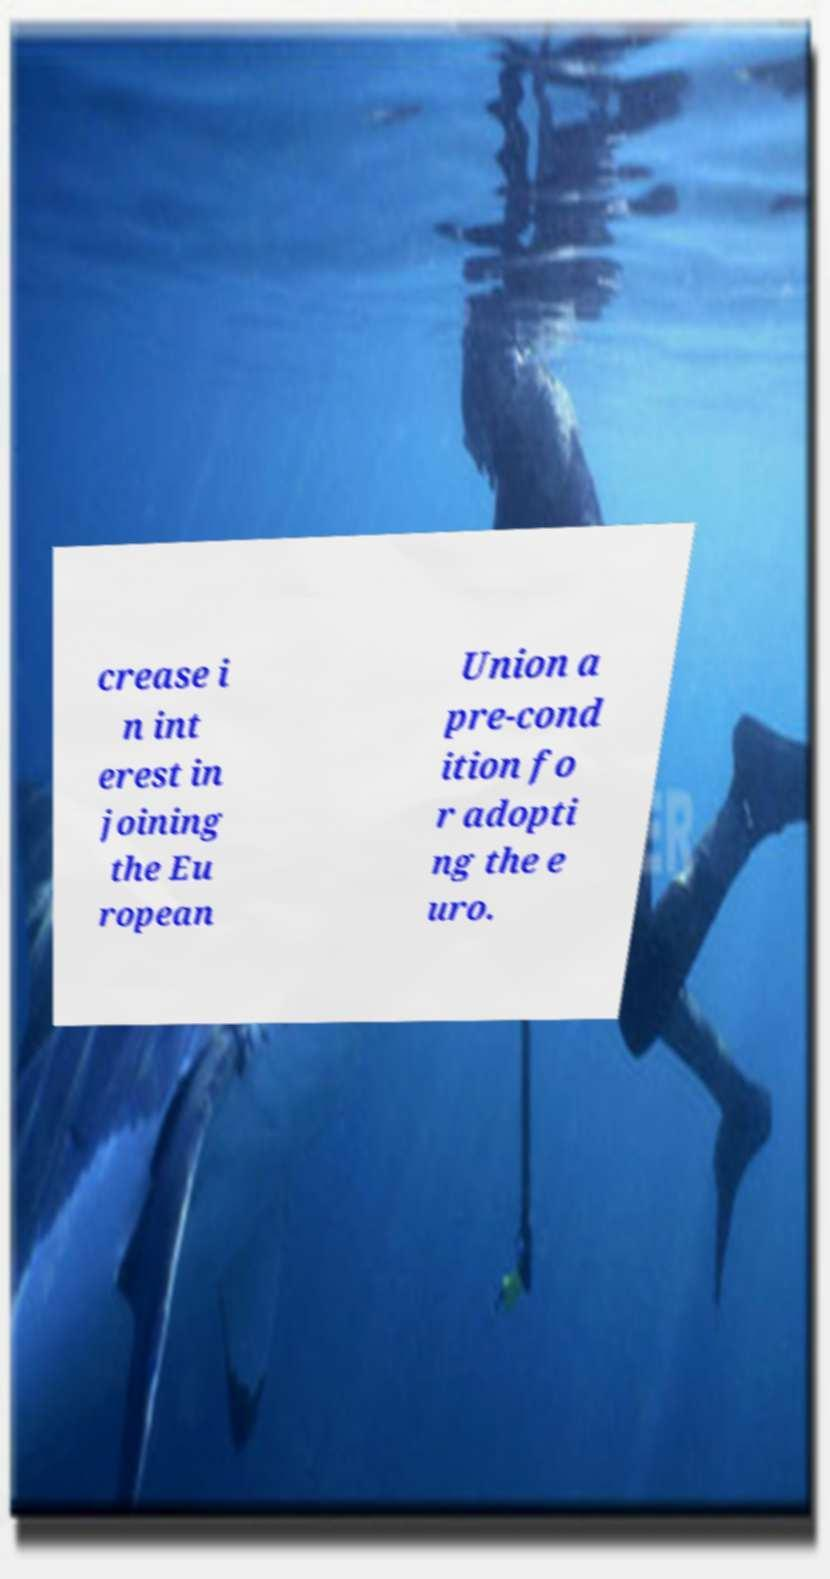There's text embedded in this image that I need extracted. Can you transcribe it verbatim? crease i n int erest in joining the Eu ropean Union a pre-cond ition fo r adopti ng the e uro. 